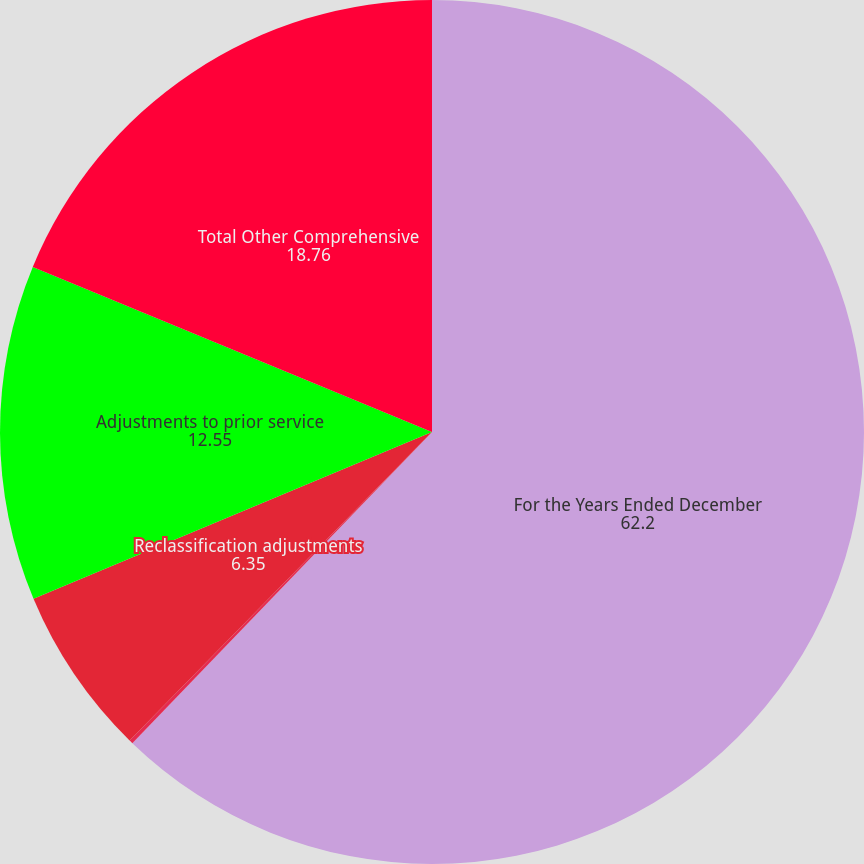Convert chart to OTSL. <chart><loc_0><loc_0><loc_500><loc_500><pie_chart><fcel>For the Years Ended December<fcel>Unrealized cash flow hedge<fcel>Reclassification adjustments<fcel>Adjustments to prior service<fcel>Total Other Comprehensive<nl><fcel>62.2%<fcel>0.14%<fcel>6.35%<fcel>12.55%<fcel>18.76%<nl></chart> 